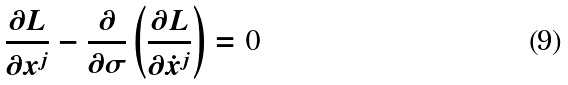Convert formula to latex. <formula><loc_0><loc_0><loc_500><loc_500>\frac { \partial L } { \partial x ^ { j } } - \frac { \partial } { \partial \sigma } \left ( \frac { \partial L } { \partial \dot { x } ^ { j } } \right ) = 0</formula> 